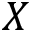<formula> <loc_0><loc_0><loc_500><loc_500>X</formula> 